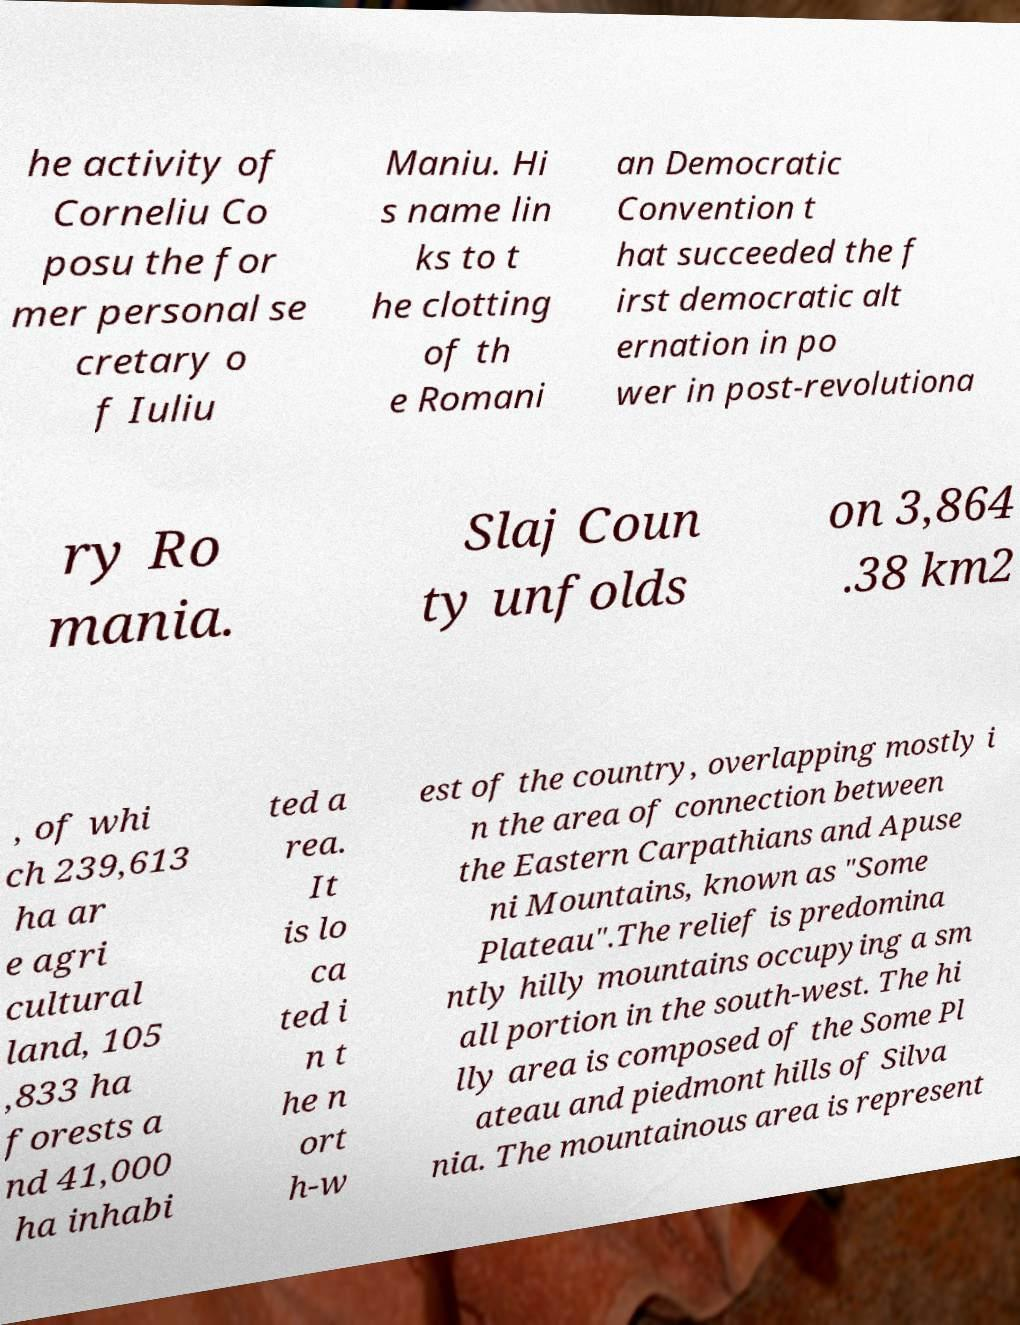Please read and relay the text visible in this image. What does it say? he activity of Corneliu Co posu the for mer personal se cretary o f Iuliu Maniu. Hi s name lin ks to t he clotting of th e Romani an Democratic Convention t hat succeeded the f irst democratic alt ernation in po wer in post-revolutiona ry Ro mania. Slaj Coun ty unfolds on 3,864 .38 km2 , of whi ch 239,613 ha ar e agri cultural land, 105 ,833 ha forests a nd 41,000 ha inhabi ted a rea. It is lo ca ted i n t he n ort h-w est of the country, overlapping mostly i n the area of connection between the Eastern Carpathians and Apuse ni Mountains, known as "Some Plateau".The relief is predomina ntly hilly mountains occupying a sm all portion in the south-west. The hi lly area is composed of the Some Pl ateau and piedmont hills of Silva nia. The mountainous area is represent 